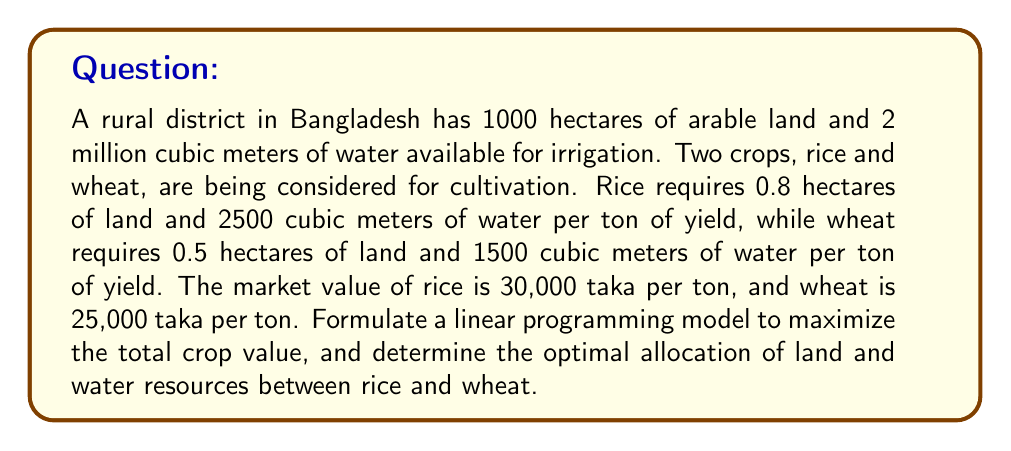Provide a solution to this math problem. Let's approach this step-by-step:

1) Define variables:
   Let $x$ = tons of rice produced
   Let $y$ = tons of wheat produced

2) Objective function:
   Maximize $Z = 30000x + 25000y$ (total crop value in taka)

3) Constraints:
   Land constraint: $0.8x + 0.5y \leq 1000$
   Water constraint: $2500x + 1500y \leq 2000000$
   Non-negativity: $x \geq 0, y \geq 0$

4) To solve this, we can use the graphical method:

   a) Plot the constraints:
      From land constraint: $y = 2000 - 1.6x$
      From water constraint: $y = 1333.33 - 1.67x$

   b) Find the corner points:
      (0, 0), (0, 1333.33), (800, 400), (1250, 0)

   c) Evaluate the objective function at each point:
      (0, 0): $Z = 0$
      (0, 1333.33): $Z = 33,333,250$
      (800, 400): $Z = 34,000,000$
      (1250, 0): $Z = 37,500,000$

5) The maximum value occurs at (800, 400), which represents:
   800 tons of rice and 400 tons of wheat

This solution uses all available land (800 * 0.8 + 400 * 0.5 = 1000 hectares) and all available water (800 * 2500 + 400 * 1500 = 2,000,000 cubic meters).
Answer: The optimal solution is to produce 800 tons of rice and 400 tons of wheat, resulting in a maximum crop value of 34,000,000 taka. 